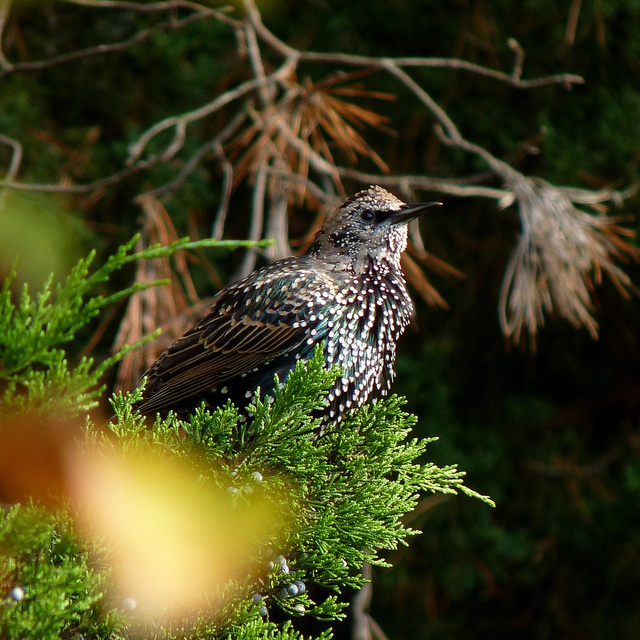Describe the objects in this image and their specific colors. I can see a bird in olive, black, gray, white, and darkgray tones in this image. 